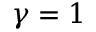<formula> <loc_0><loc_0><loc_500><loc_500>\gamma = 1</formula> 